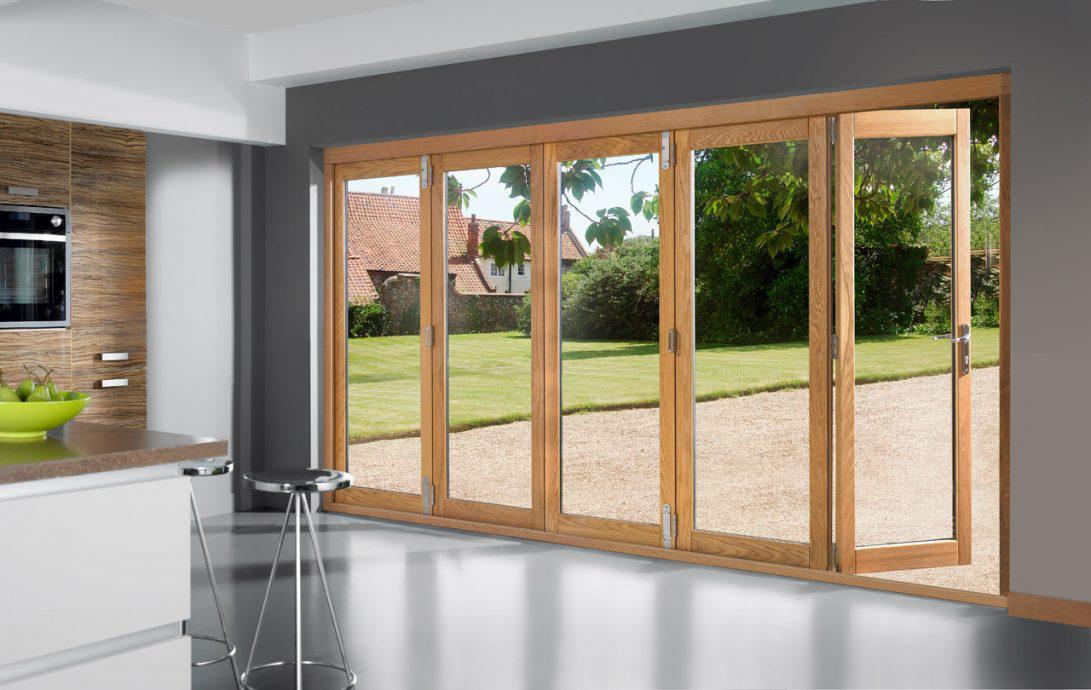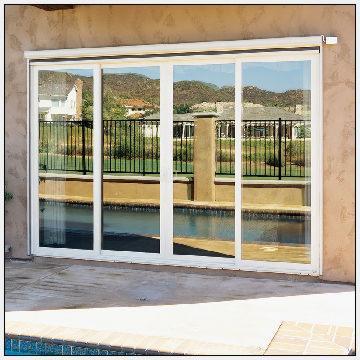The first image is the image on the left, the second image is the image on the right. Evaluate the accuracy of this statement regarding the images: "All the doors are closed.". Is it true? Answer yes or no. No. The first image is the image on the left, the second image is the image on the right. Examine the images to the left and right. Is the description "There is at least one chair visible through the sliding glass doors." accurate? Answer yes or no. No. 